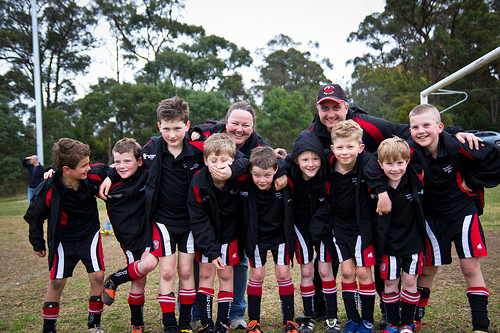<image>
Can you confirm if the short boy is to the right of the tall boy? Yes. From this viewpoint, the short boy is positioned to the right side relative to the tall boy. 